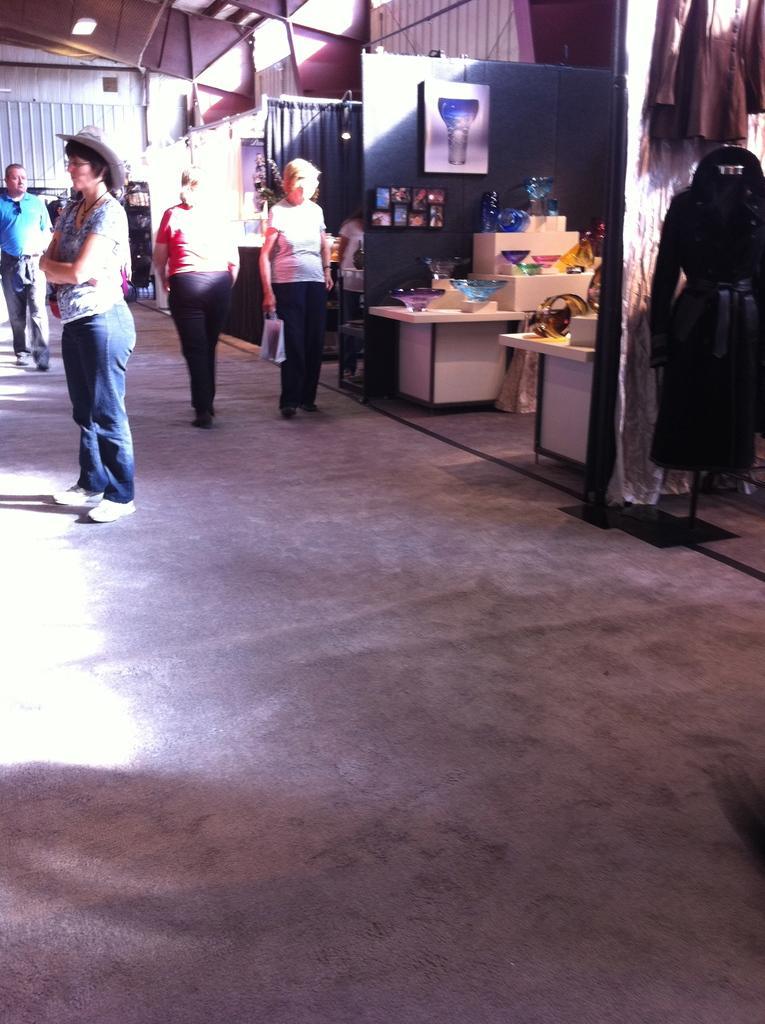Can you describe this image briefly? In the image there are four people two people are walking and two people are standing. There are stalls on the right side of the image, there are jackets and bowls and at the top of the image there is a light. 